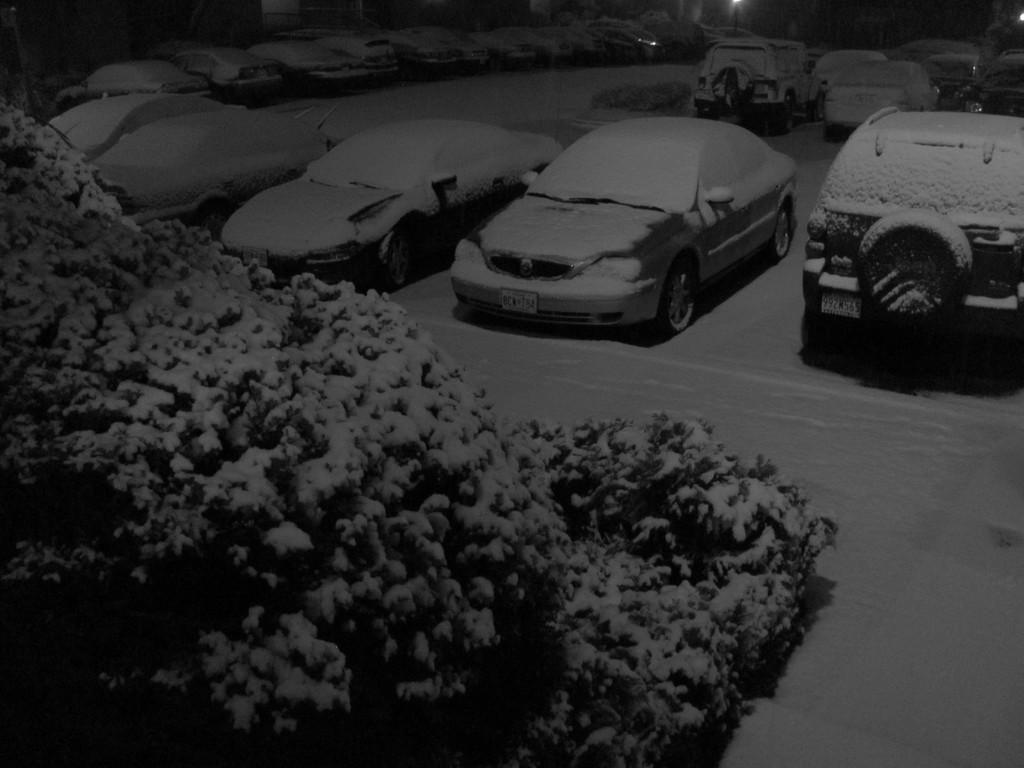What can be seen in large numbers in the image? There are many cars parked in the image. What natural element is present on the left side of the image? There is a tree on the left side of the image. What weather condition is depicted in the image? There is snow visible in the image. What source of illumination can be seen in the image? There is a light in the image. How would you describe the overall lighting conditions in the image? The image appears to be dark or in low light conditions. How many boys are holding bananas in the image? There are no boys or bananas present in the image. Is there any visible print on the cars in the image? The image does not provide information about any visible print on the cars. 